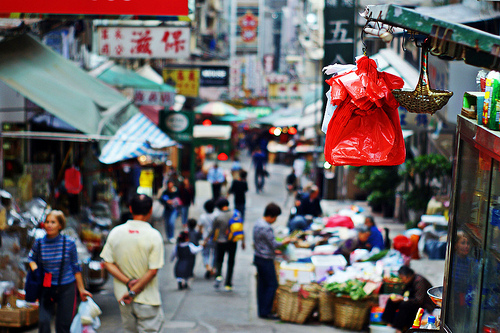<image>
Can you confirm if the bag is to the right of the purse? No. The bag is not to the right of the purse. The horizontal positioning shows a different relationship. 